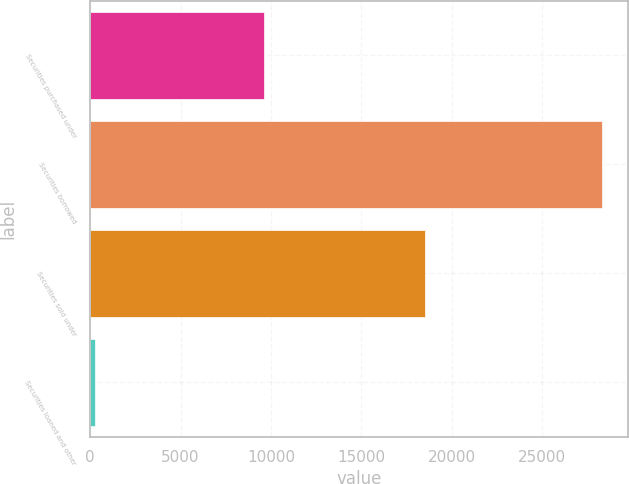<chart> <loc_0><loc_0><loc_500><loc_500><bar_chart><fcel>Securities purchased under<fcel>Securities borrowed<fcel>Securities sold under<fcel>Securities loaned and other<nl><fcel>9601<fcel>28307<fcel>18535<fcel>263<nl></chart> 